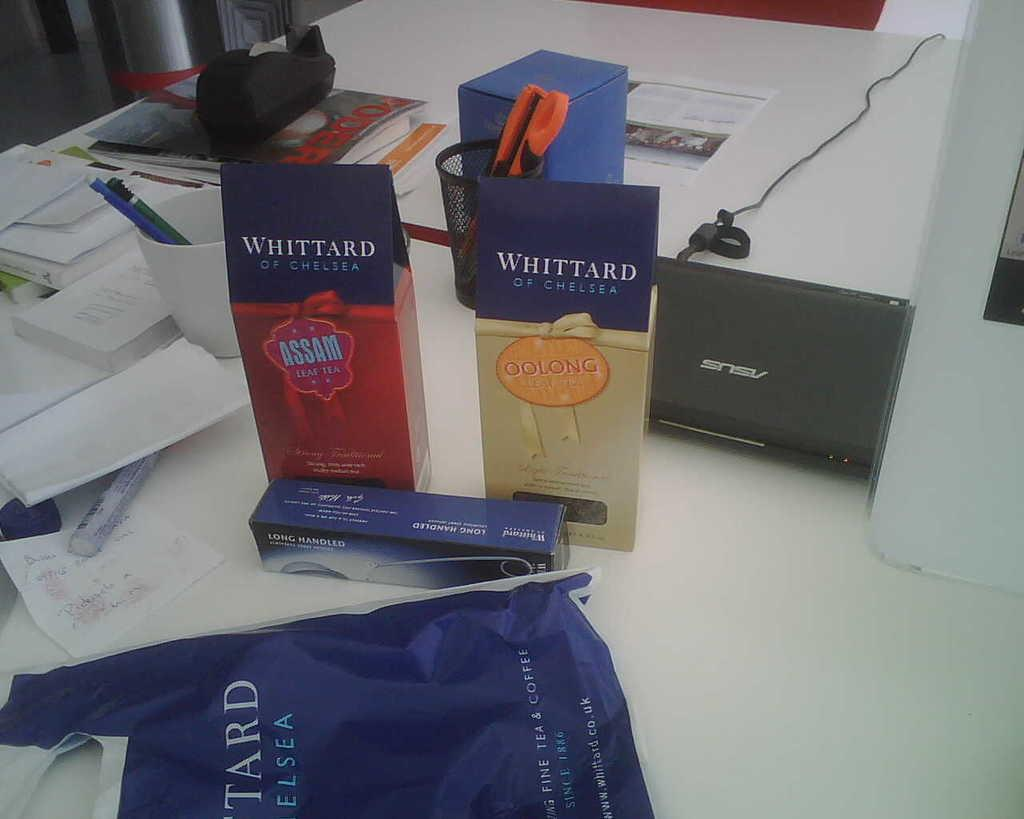Provide a one-sentence caption for the provided image. A table with a laptop and a plastic bag is sitting beside some boxes that one of which says Whittard Of Chelsea Oolong on it. 